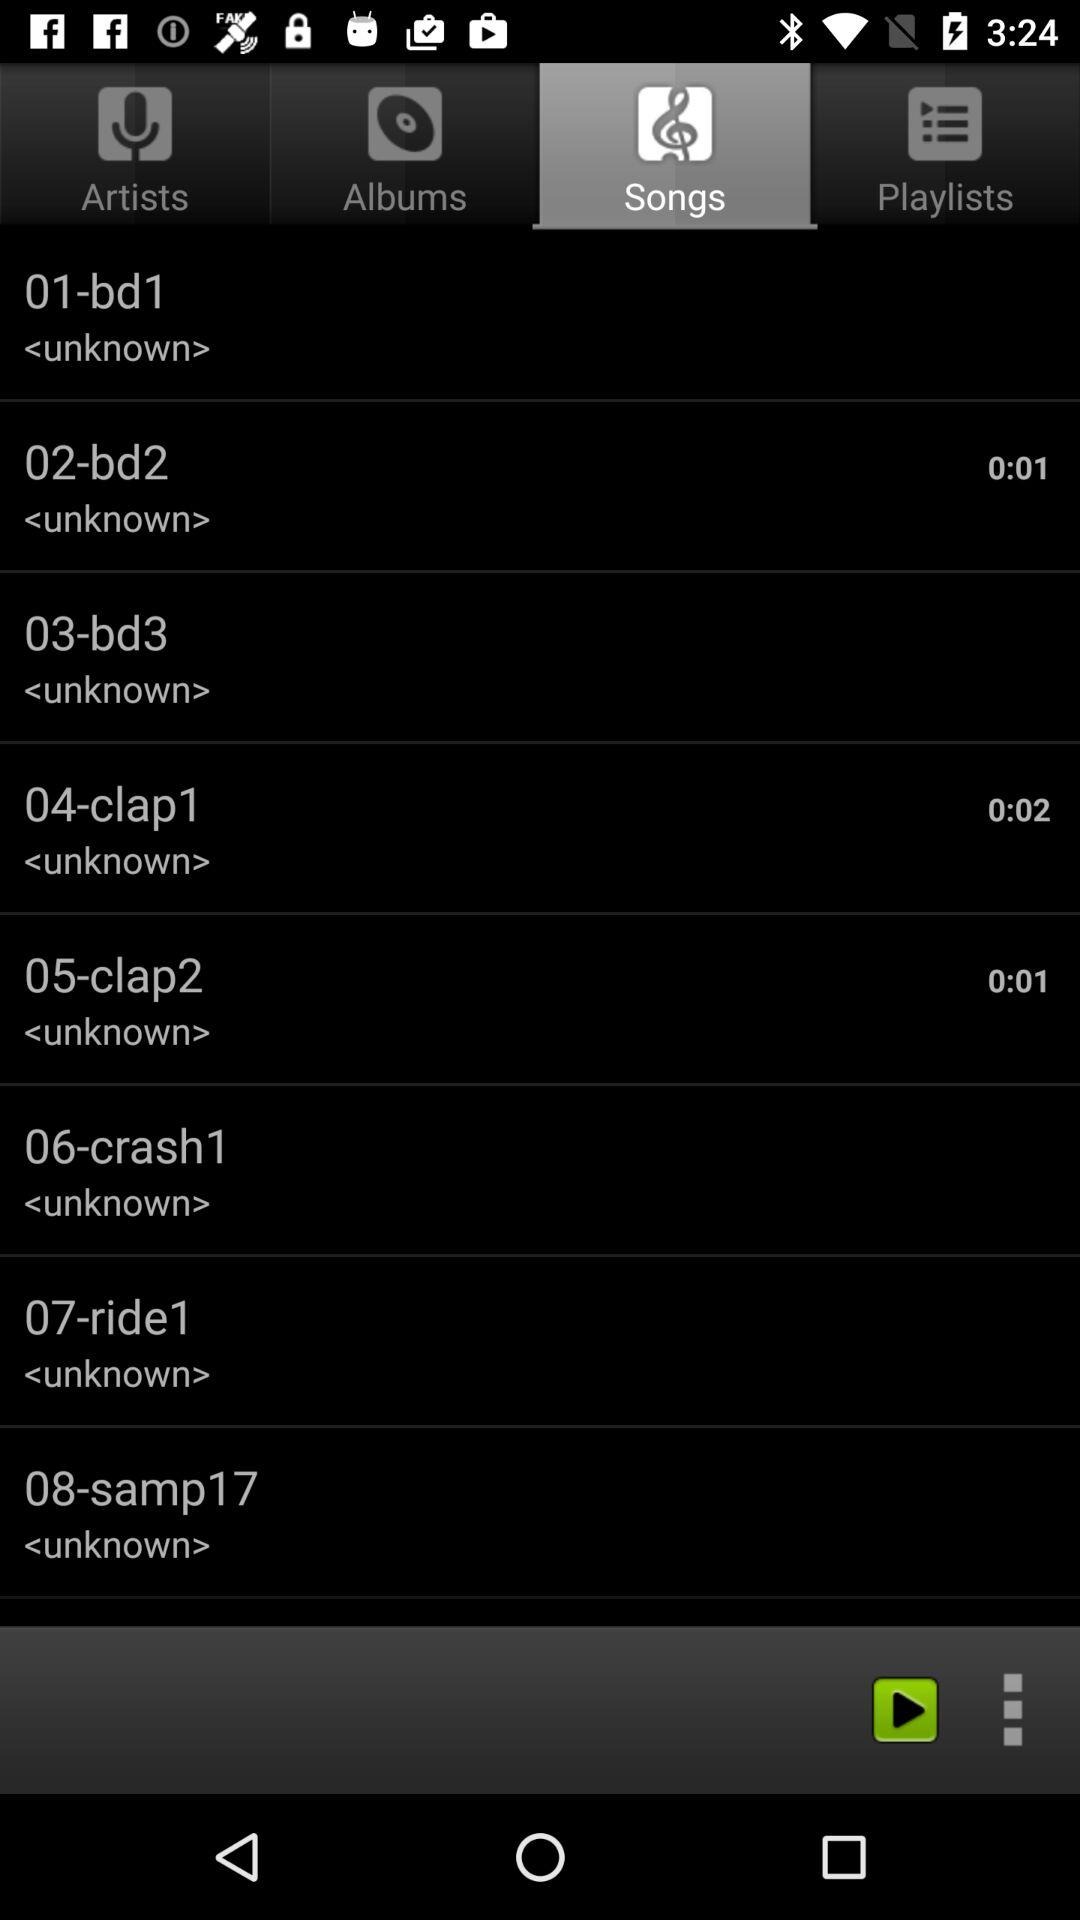0.02 seconds is the duration of which song? 0.02 seconds is the duration of the "clap1" song. 